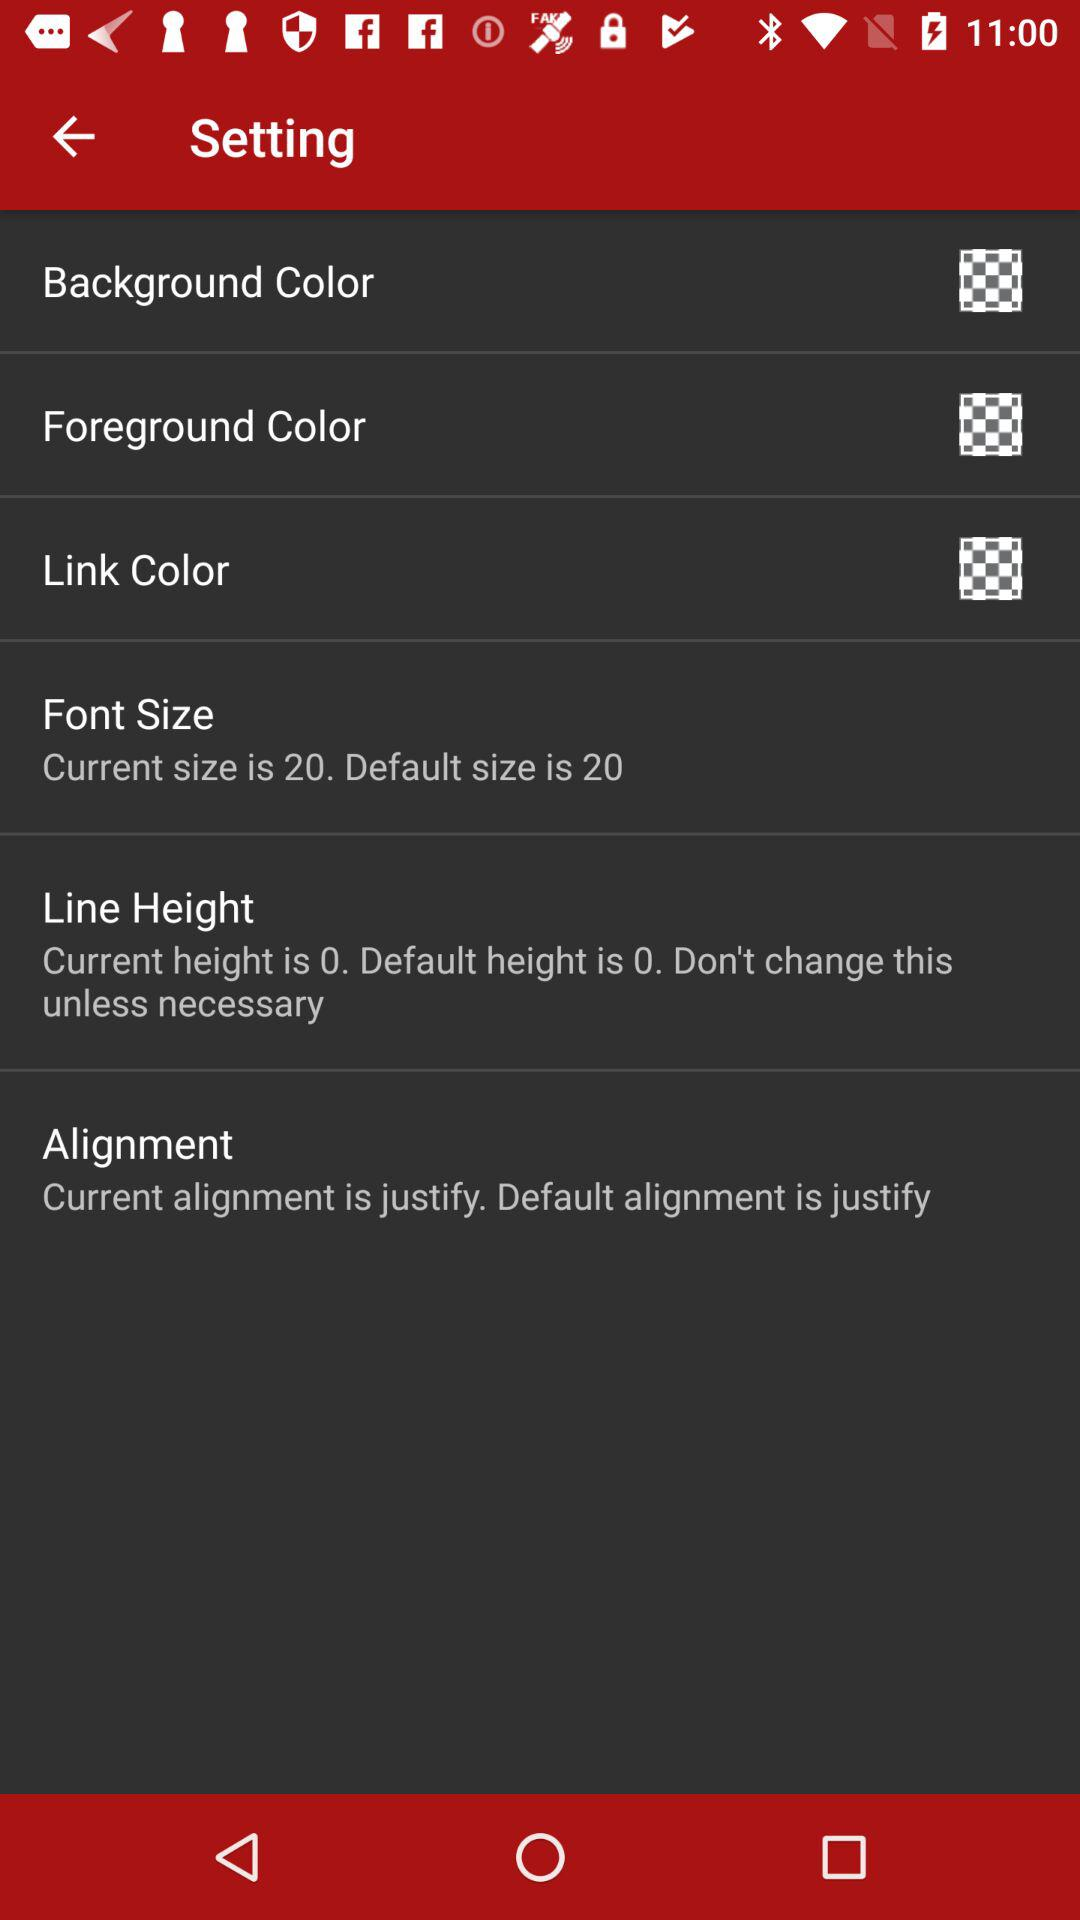How many items have a current value that is the same as the default value?
Answer the question using a single word or phrase. 3 